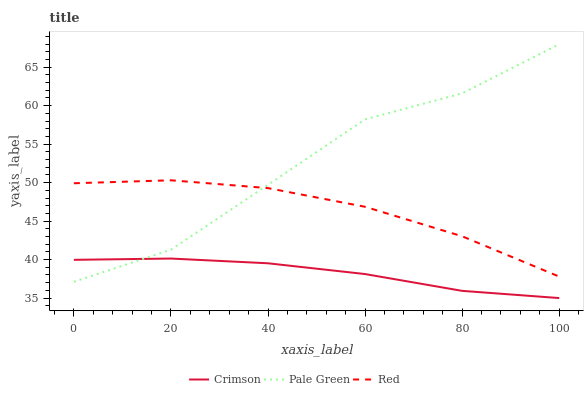Does Crimson have the minimum area under the curve?
Answer yes or no. Yes. Does Pale Green have the maximum area under the curve?
Answer yes or no. Yes. Does Red have the minimum area under the curve?
Answer yes or no. No. Does Red have the maximum area under the curve?
Answer yes or no. No. Is Crimson the smoothest?
Answer yes or no. Yes. Is Pale Green the roughest?
Answer yes or no. Yes. Is Red the smoothest?
Answer yes or no. No. Is Red the roughest?
Answer yes or no. No. Does Crimson have the lowest value?
Answer yes or no. Yes. Does Pale Green have the lowest value?
Answer yes or no. No. Does Pale Green have the highest value?
Answer yes or no. Yes. Does Red have the highest value?
Answer yes or no. No. Is Crimson less than Red?
Answer yes or no. Yes. Is Red greater than Crimson?
Answer yes or no. Yes. Does Pale Green intersect Red?
Answer yes or no. Yes. Is Pale Green less than Red?
Answer yes or no. No. Is Pale Green greater than Red?
Answer yes or no. No. Does Crimson intersect Red?
Answer yes or no. No. 